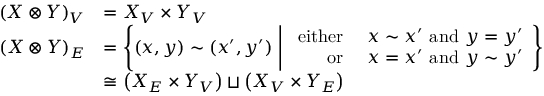Convert formula to latex. <formula><loc_0><loc_0><loc_500><loc_500>\begin{array} { r l } { { ( X \otimes Y ) } _ { V } } & { = { X } _ { V } \times { Y } _ { V } } \\ { { ( X \otimes Y ) } _ { E } } & { = \left \{ \left ( x , y \right ) \sim \left ( x ^ { \prime } , y ^ { \prime } \right ) \ | d l e | \ \begin{array} { r l } { e i t h e r } & { x \sim x ^ { \prime } a n d y = y ^ { \prime } } \\ { o r } & { x = x ^ { \prime } a n d y \sim y ^ { \prime } } \end{array} \right \} } \\ & { \cong \left ( { X } _ { E } \times { Y } _ { V } \right ) \sqcup \left ( { X } _ { V } \times { Y } _ { E } \right ) } \end{array}</formula> 